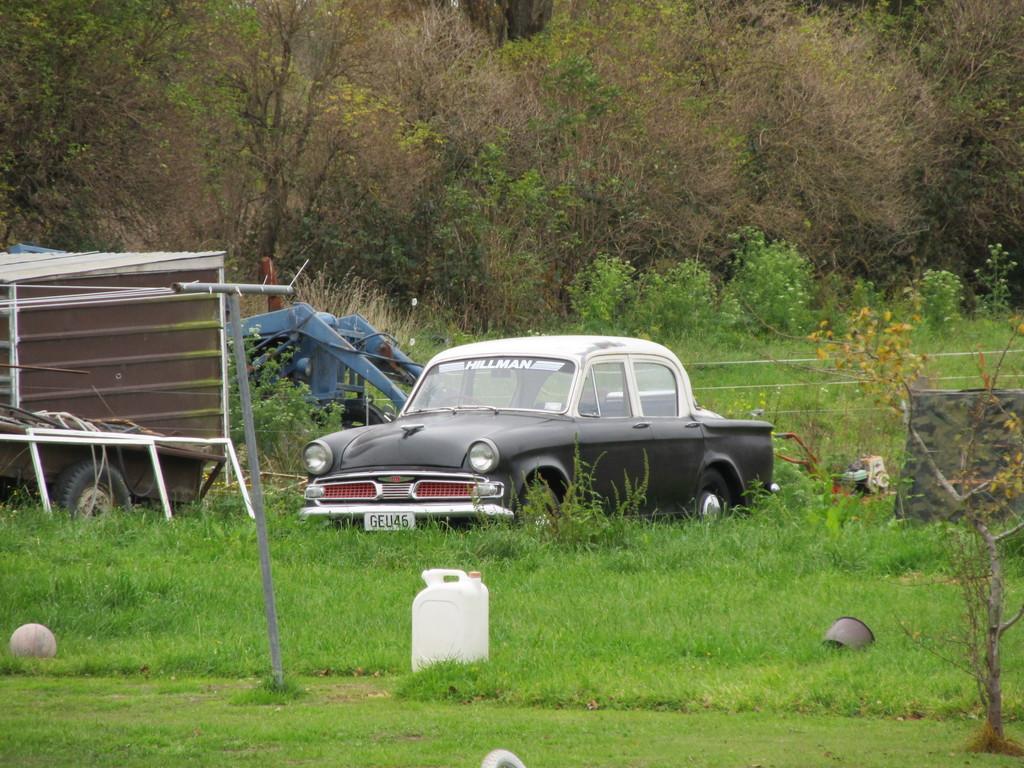In one or two sentences, can you explain what this image depicts? In this image I can see car which is in gray color, at the back I can see trees and grass in green color, at left I can see the other vehicle. 